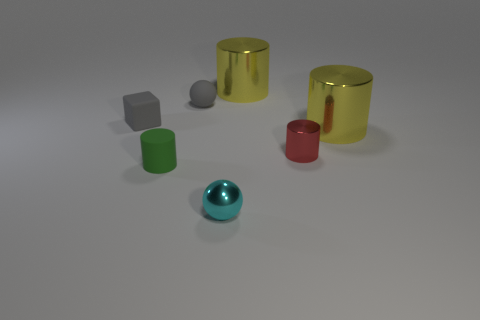What is the green cylinder made of?
Offer a terse response. Rubber. There is a rubber object in front of the large shiny object that is in front of the ball that is behind the tiny cyan shiny thing; what shape is it?
Provide a short and direct response. Cylinder. Are there more small red shiny cylinders that are to the left of the cyan metallic sphere than small red metallic objects?
Ensure brevity in your answer.  No. There is a tiny red shiny object; does it have the same shape as the small metallic object to the left of the red cylinder?
Provide a succinct answer. No. There is a small matte object that is the same color as the tiny rubber ball; what is its shape?
Offer a very short reply. Cube. How many large yellow metallic things are on the right side of the metallic cylinder behind the yellow shiny cylinder that is in front of the tiny matte sphere?
Provide a short and direct response. 1. There is a shiny cylinder that is the same size as the rubber sphere; what is its color?
Your answer should be very brief. Red. What is the size of the matte object that is in front of the small red cylinder that is right of the green cylinder?
Provide a succinct answer. Small. What size is the rubber thing that is the same color as the block?
Provide a succinct answer. Small. How many other objects are the same size as the red cylinder?
Give a very brief answer. 4. 